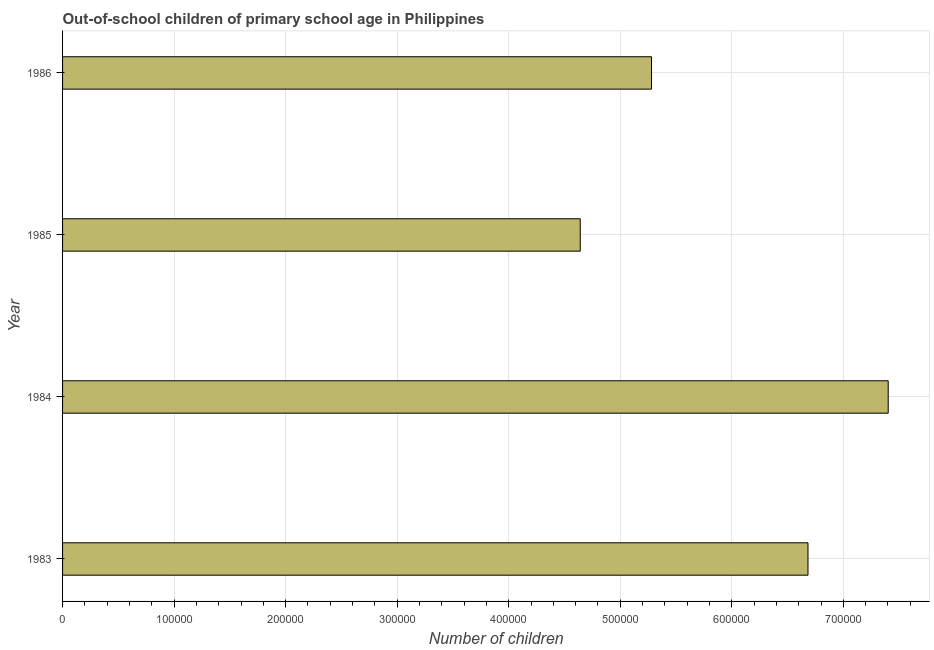What is the title of the graph?
Provide a short and direct response. Out-of-school children of primary school age in Philippines. What is the label or title of the X-axis?
Keep it short and to the point. Number of children. What is the number of out-of-school children in 1983?
Your answer should be very brief. 6.68e+05. Across all years, what is the maximum number of out-of-school children?
Offer a terse response. 7.40e+05. Across all years, what is the minimum number of out-of-school children?
Offer a terse response. 4.64e+05. In which year was the number of out-of-school children minimum?
Your answer should be compact. 1985. What is the sum of the number of out-of-school children?
Provide a short and direct response. 2.40e+06. What is the difference between the number of out-of-school children in 1983 and 1986?
Make the answer very short. 1.40e+05. What is the average number of out-of-school children per year?
Offer a terse response. 6.00e+05. What is the median number of out-of-school children?
Ensure brevity in your answer.  5.98e+05. Do a majority of the years between 1984 and 1985 (inclusive) have number of out-of-school children greater than 540000 ?
Make the answer very short. No. What is the ratio of the number of out-of-school children in 1984 to that in 1986?
Ensure brevity in your answer.  1.4. Is the number of out-of-school children in 1984 less than that in 1985?
Your response must be concise. No. Is the difference between the number of out-of-school children in 1984 and 1986 greater than the difference between any two years?
Your answer should be compact. No. What is the difference between the highest and the second highest number of out-of-school children?
Provide a short and direct response. 7.19e+04. What is the difference between the highest and the lowest number of out-of-school children?
Offer a terse response. 2.76e+05. How many bars are there?
Keep it short and to the point. 4. How many years are there in the graph?
Ensure brevity in your answer.  4. Are the values on the major ticks of X-axis written in scientific E-notation?
Your answer should be very brief. No. What is the Number of children in 1983?
Keep it short and to the point. 6.68e+05. What is the Number of children of 1984?
Provide a short and direct response. 7.40e+05. What is the Number of children in 1985?
Offer a very short reply. 4.64e+05. What is the Number of children of 1986?
Provide a succinct answer. 5.28e+05. What is the difference between the Number of children in 1983 and 1984?
Offer a very short reply. -7.19e+04. What is the difference between the Number of children in 1983 and 1985?
Your response must be concise. 2.04e+05. What is the difference between the Number of children in 1983 and 1986?
Your response must be concise. 1.40e+05. What is the difference between the Number of children in 1984 and 1985?
Your answer should be very brief. 2.76e+05. What is the difference between the Number of children in 1984 and 1986?
Your answer should be very brief. 2.12e+05. What is the difference between the Number of children in 1985 and 1986?
Your answer should be very brief. -6.39e+04. What is the ratio of the Number of children in 1983 to that in 1984?
Offer a very short reply. 0.9. What is the ratio of the Number of children in 1983 to that in 1985?
Your answer should be compact. 1.44. What is the ratio of the Number of children in 1983 to that in 1986?
Provide a succinct answer. 1.27. What is the ratio of the Number of children in 1984 to that in 1985?
Your answer should be very brief. 1.59. What is the ratio of the Number of children in 1984 to that in 1986?
Offer a terse response. 1.4. What is the ratio of the Number of children in 1985 to that in 1986?
Your response must be concise. 0.88. 